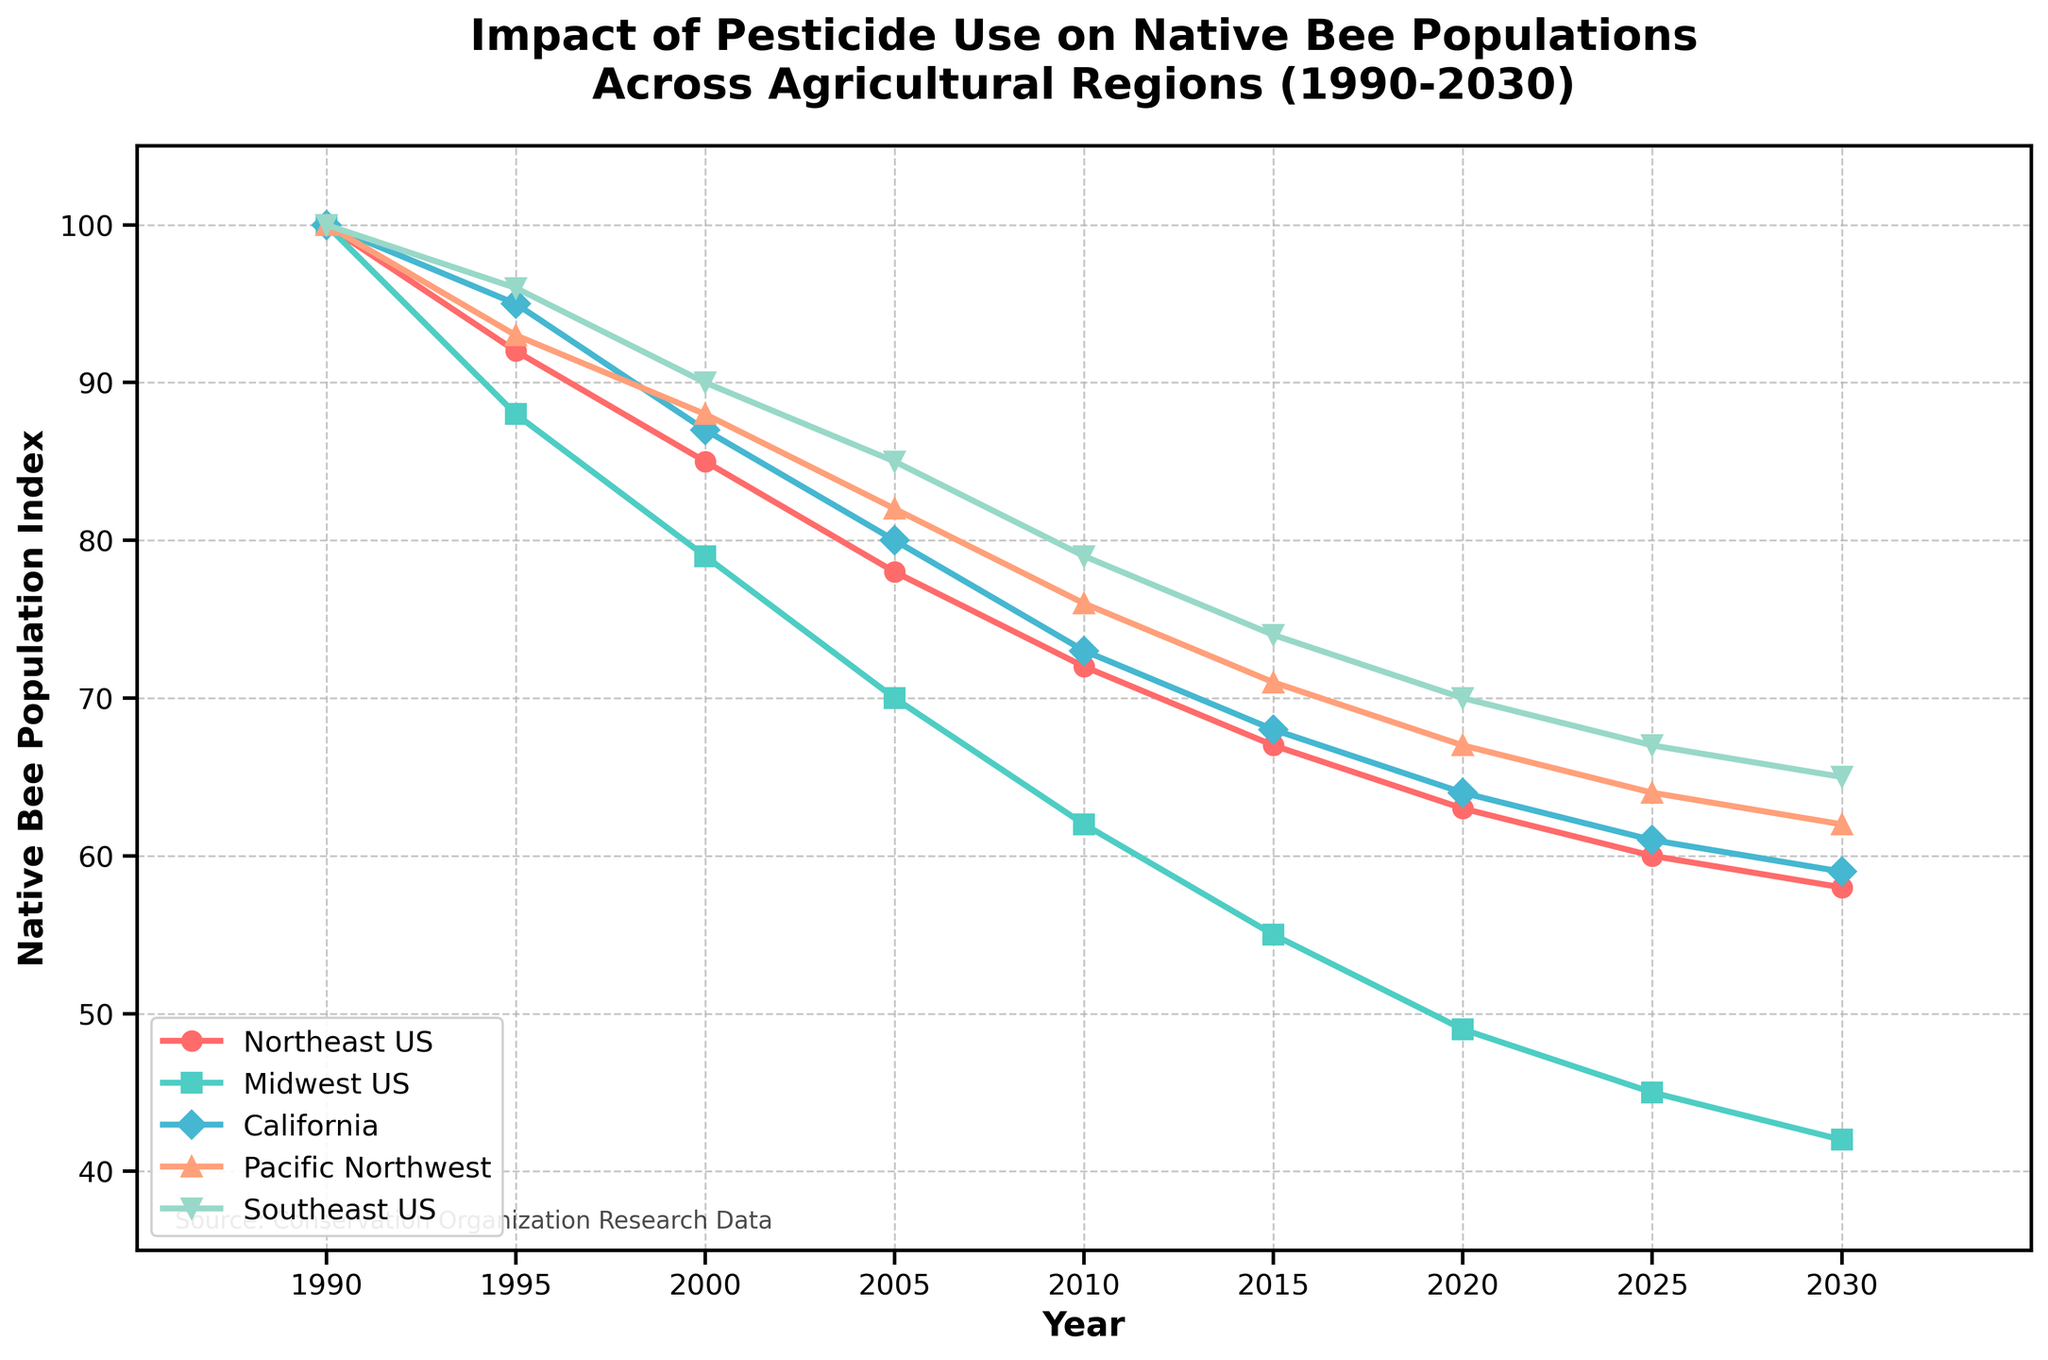What is the general trend of native bee populations in the California region? The trend of the native bee population in California can be observed by looking at the series representing California from 1990 to 2030. The line graph for California shows a decline over time. Starting from a population index of 100 in 1990, it gradually decreases to 59 by 2030.
Answer: The trend is a steady decline Which region has the lowest native bee population in 2030? To find the lowest native bee population in 2030, compare the population indices for all regions in 2030. The values are: Northeast US (58), Midwest US (42), California (59), Pacific Northwest (62), and Southeast US (65). The lowest value is in the Midwest US with a population index of 42.
Answer: Midwest US Compare the trends of native bee populations in the Northeast US and Southeast US from 1990 to 2030. Both trends show a decline over time, but they have different rates of decline. Northeast US starts from 100 in 1990 and declines more sharply, reaching 58 in 2030. Southeast US also starts from 100 in 1990 but declines more gradually, reaching 65 in 2030. Thus, the Northeast US has a steeper decline compared to the Southeast US.
Answer: Northeast US declines more steeply than Southeast US What year does the native bee population in the Pacific Northwest drop below 70? Follow the Pacific Northwest population line on the graph and identify the year when it drops below 70. The line falls below 70 between 2015 and 2020. Specifically, in 2020, the population index is 67, confirming it drops below 70 in 2020.
Answer: 2020 Which region experienced the sharpest decline in native bee populations by percentage from 1990 to 2030? Calculate the percentage decline for each region from 1990 to 2030:
- Northeast US: ((100 - 58) / 100) * 100 = 42%
- Midwest US: ((100 - 42) / 100) * 100 = 58%
- California: ((100 - 59) / 100) * 100 = 41%
- Pacific Northwest: ((100 - 62) / 100) * 100 = 38%
- Southeast US: ((100 - 65) / 100) * 100 = 35%
The Midwest US has the highest percentage decline at 58%.
Answer: Midwest US Estimate the average native bee population index in the Pacific Northwest from 1990 to 2030. Sum the population indices for the Pacific Northwest over the given years and divide by the number of years. The values are 100, 93, 88, 82, 76, 71, 67, 64, and 62. The sum is 703. There are 9 data points, so the average is 703 / 9 ≈ 78.1.
Answer: 78.1 What year did the Midwest US region have the largest decline in native bee populations compared to the previous period? Identify the year-to-year changes in the Midwest US line. The largest drop occurs between 1995 and 2000, where the population index drops from 88 to 79, a difference of 9 points.
Answer: Between 1995 and 2000 In 2025, which regions have a higher native bee population than the Midwest US? Compare the population indices of all regions in 2025:
- Northeast US: 60
- Midwest US: 45
- California: 61
- Pacific Northwest: 64
- Southeast US: 67
California, Pacific Northwest, and Southeast US have higher population indices than the Midwest US in 2025.
Answer: California, Pacific Northwest, and Southeast US 